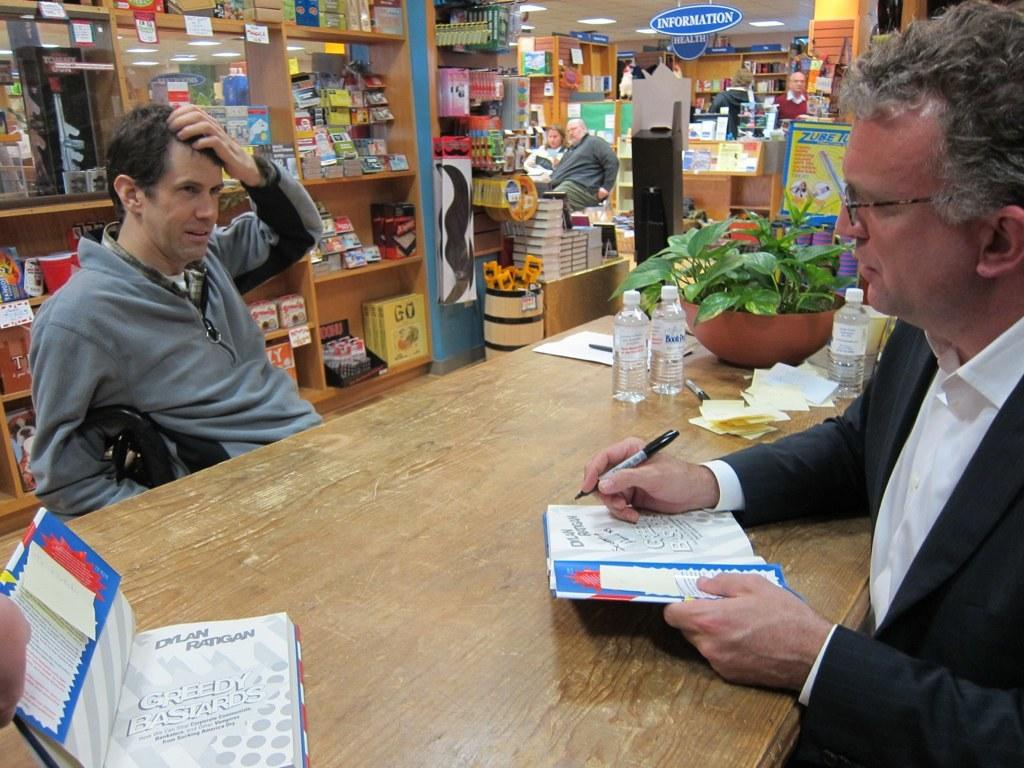Provide a one-sentence caption for the provided image. A man signing books authored by Dylan Ratigan with the name Greedy Bastards. 